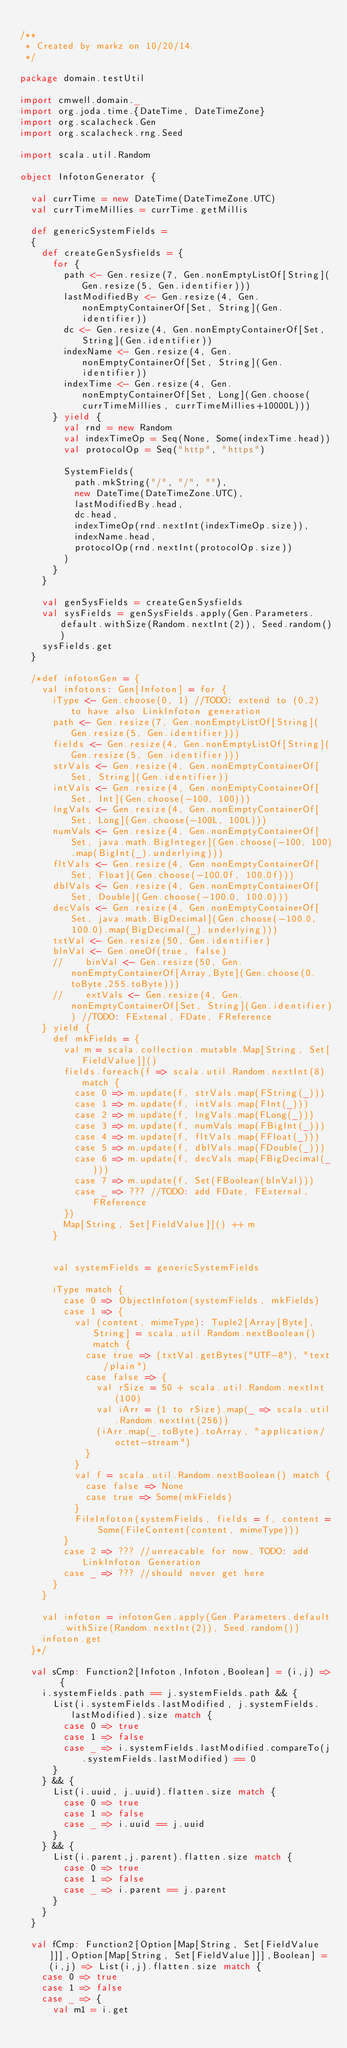Convert code to text. <code><loc_0><loc_0><loc_500><loc_500><_Scala_>
/**
 * Created by markz on 10/20/14.
 */

package domain.testUtil

import cmwell.domain._
import org.joda.time.{DateTime, DateTimeZone}
import org.scalacheck.Gen
import org.scalacheck.rng.Seed

import scala.util.Random

object InfotonGenerator {

  val currTime = new DateTime(DateTimeZone.UTC)
  val currTimeMillies = currTime.getMillis

  def genericSystemFields =
  {
    def createGenSysfields = {
      for {
        path <- Gen.resize(7, Gen.nonEmptyListOf[String](Gen.resize(5, Gen.identifier)))
        lastModifiedBy <- Gen.resize(4, Gen.nonEmptyContainerOf[Set, String](Gen.identifier))
        dc <- Gen.resize(4, Gen.nonEmptyContainerOf[Set, String](Gen.identifier))
        indexName <- Gen.resize(4, Gen.nonEmptyContainerOf[Set, String](Gen.identifier))
        indexTime <- Gen.resize(4, Gen.nonEmptyContainerOf[Set, Long](Gen.choose(currTimeMillies, currTimeMillies+10000L)))
      } yield {
        val rnd = new Random
        val indexTimeOp = Seq(None, Some(indexTime.head))
        val protocolOp = Seq("http", "https")

        SystemFields(
          path.mkString("/", "/", ""),
          new DateTime(DateTimeZone.UTC),
          lastModifiedBy.head,
          dc.head,
          indexTimeOp(rnd.nextInt(indexTimeOp.size)),
          indexName.head,
          protocolOp(rnd.nextInt(protocolOp.size))
        )
      }
    }

    val genSysFields = createGenSysfields
    val sysFields = genSysFields.apply(Gen.Parameters.default.withSize(Random.nextInt(2)), Seed.random())
    sysFields.get
  }

  /*def infotonGen = {
    val infotons: Gen[Infoton] = for {
      iType <- Gen.choose(0, 1) //TODO: extend to (0,2) to have also LinkInfoton generation
      path <- Gen.resize(7, Gen.nonEmptyListOf[String](Gen.resize(5, Gen.identifier)))
      fields <- Gen.resize(4, Gen.nonEmptyListOf[String](Gen.resize(5, Gen.identifier)))
      strVals <- Gen.resize(4, Gen.nonEmptyContainerOf[Set, String](Gen.identifier))
      intVals <- Gen.resize(4, Gen.nonEmptyContainerOf[Set, Int](Gen.choose(-100, 100)))
      lngVals <- Gen.resize(4, Gen.nonEmptyContainerOf[Set, Long](Gen.choose(-100L, 100L)))
      numVals <- Gen.resize(4, Gen.nonEmptyContainerOf[Set, java.math.BigInteger](Gen.choose(-100, 100).map(BigInt(_).underlying)))
      fltVals <- Gen.resize(4, Gen.nonEmptyContainerOf[Set, Float](Gen.choose(-100.0f, 100.0f)))
      dblVals <- Gen.resize(4, Gen.nonEmptyContainerOf[Set, Double](Gen.choose(-100.0, 100.0)))
      decVals <- Gen.resize(4, Gen.nonEmptyContainerOf[Set, java.math.BigDecimal](Gen.choose(-100.0, 100.0).map(BigDecimal(_).underlying)))
      txtVal <- Gen.resize(50, Gen.identifier)
      blnVal <- Gen.oneOf(true, false)
      //    binVal <- Gen.resize(50, Gen.nonEmptyContainerOf[Array,Byte](Gen.choose(0.toByte,255.toByte)))
      //    extVals <- Gen.resize(4, Gen.nonEmptyContainerOf[Set, String](Gen.identifier)) //TODO: FExtenal, FDate, FReference
    } yield {
      def mkFields = {
        val m = scala.collection.mutable.Map[String, Set[FieldValue]]()
        fields.foreach(f => scala.util.Random.nextInt(8) match {
          case 0 => m.update(f, strVals.map(FString(_)))
          case 1 => m.update(f, intVals.map(FInt(_)))
          case 2 => m.update(f, lngVals.map(FLong(_)))
          case 3 => m.update(f, numVals.map(FBigInt(_)))
          case 4 => m.update(f, fltVals.map(FFloat(_)))
          case 5 => m.update(f, dblVals.map(FDouble(_)))
          case 6 => m.update(f, decVals.map(FBigDecimal(_)))
          case 7 => m.update(f, Set(FBoolean(blnVal)))
          case _ => ??? //TODO: add FDate, FExternal, FReference
        })
        Map[String, Set[FieldValue]]() ++ m
      }


      val systemFields = genericSystemFields

      iType match {
        case 0 => ObjectInfoton(systemFields, mkFields)
        case 1 => {
          val (content, mimeType): Tuple2[Array[Byte], String] = scala.util.Random.nextBoolean() match {
            case true => (txtVal.getBytes("UTF-8"), "text/plain")
            case false => {
              val rSize = 50 + scala.util.Random.nextInt(100)
              val iArr = (1 to rSize).map(_ => scala.util.Random.nextInt(256))
              (iArr.map(_.toByte).toArray, "application/octet-stream")
            }
          }
          val f = scala.util.Random.nextBoolean() match {
            case false => None
            case true => Some(mkFields)
          }
          FileInfoton(systemFields, fields = f, content = Some(FileContent(content, mimeType)))
        }
        case 2 => ??? //unreacable for now, TODO: add LinkInfoton Generation
        case _ => ??? //should never get here
      }
    }

    val infoton = infotonGen.apply(Gen.Parameters.default.withSize(Random.nextInt(2)), Seed.random())
    infoton.get
  }*/

  val sCmp: Function2[Infoton,Infoton,Boolean] = (i,j) =>  {
    i.systemFields.path == j.systemFields.path && {
      List(i.systemFields.lastModified, j.systemFields.lastModified).size match {
        case 0 => true
        case 1 => false
        case _ => i.systemFields.lastModified.compareTo(j.systemFields.lastModified) == 0
      }
    } && {
      List(i.uuid, j.uuid).flatten.size match {
        case 0 => true
        case 1 => false
        case _ => i.uuid == j.uuid
      }
    } && {
      List(i.parent,j.parent).flatten.size match {
        case 0 => true
        case 1 => false
        case _ => i.parent == j.parent
      }
    }
  }

  val fCmp: Function2[Option[Map[String, Set[FieldValue]]],Option[Map[String, Set[FieldValue]]],Boolean] = (i,j) => List(i,j).flatten.size match {
    case 0 => true
    case 1 => false
    case _ => {
      val m1 = i.get</code> 